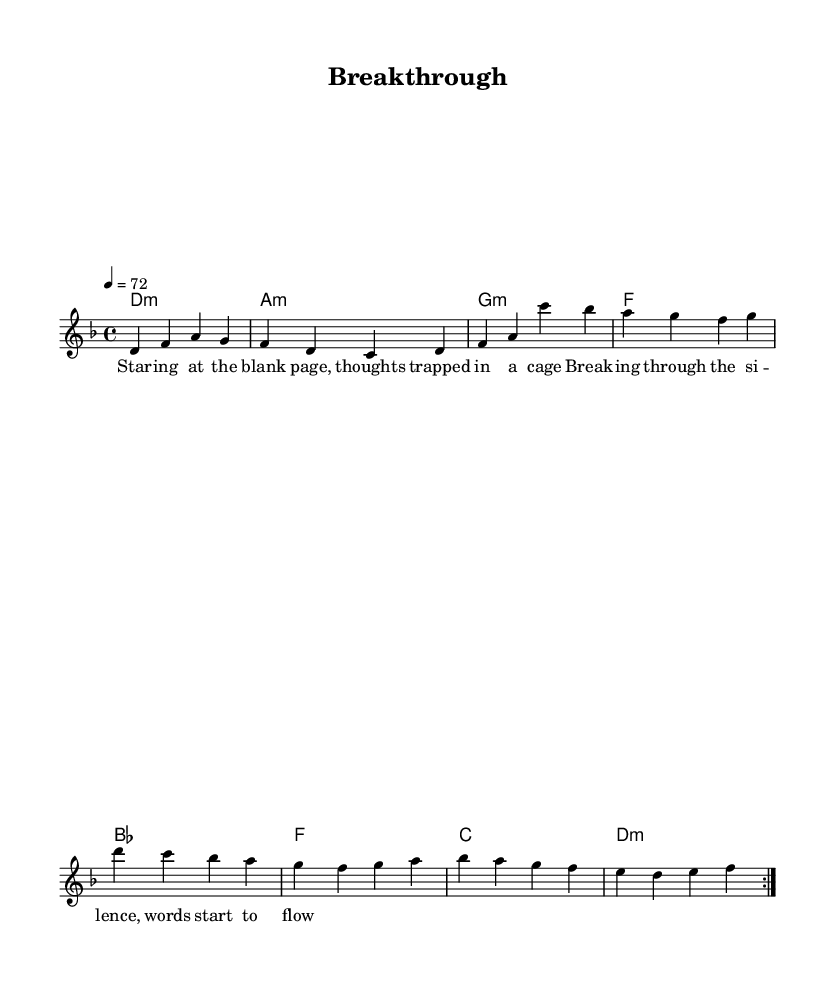What is the key signature of this music? The key signature indicates that the piece is in D minor, which has one flat (B flat).
Answer: D minor What is the time signature of this music? The time signature is 4/4, meaning there are four beats per measure.
Answer: 4/4 What is the tempo marking of this piece? The tempo marking is 72 beats per minute, as indicated by the notation "4 = 72."
Answer: 72 How many measures are in the repeat section? The repeat section consists of 8 measures, as there are two repeats of a 4-measure phrase.
Answer: 8 What is the first note of the melody? The first note of the melody is D, as shown in the first measure.
Answer: D What is the main theme of the chorus lyrics? The main theme of the chorus lyrics focuses on overcoming silence and allowing words to flow freely.
Answer: Overcoming silence What type of harmony is predominantly used in this piece? The piece predominantly uses minor chords, particularly evident in the chord progression.
Answer: Minor chords 